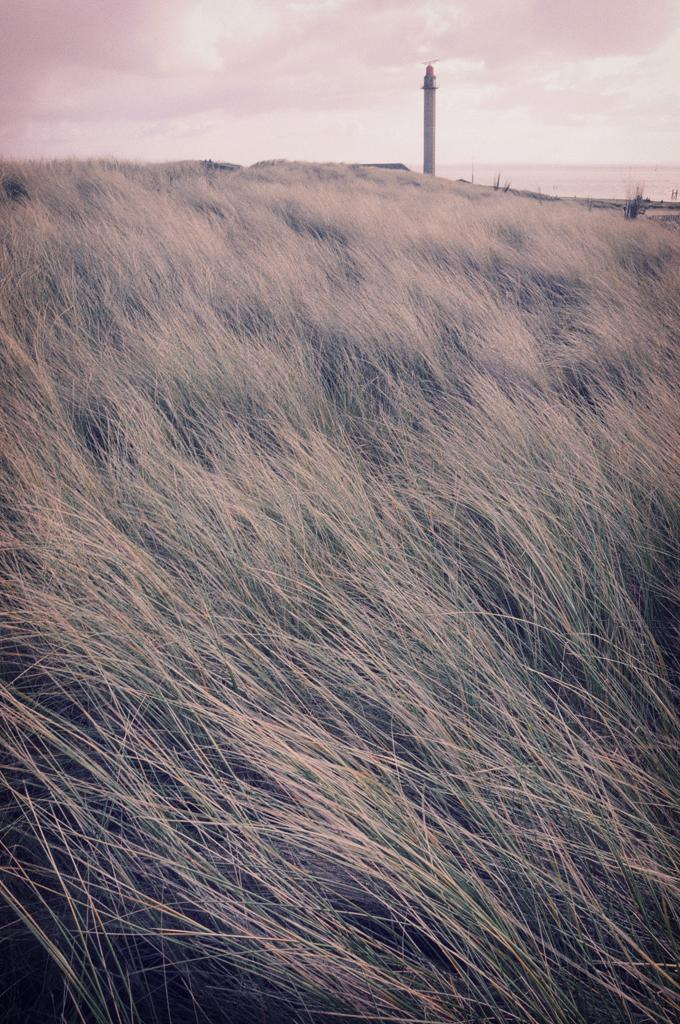What type of vegetation is in the foreground of the image? There is grass in the foreground of the image. What type of structure can be seen in the background of the image? There is a lighthouse in the background of the image. What natural element is visible in the background of the image? There is water visible in the background of the image. What else can be seen in the sky in the background of the image? There are clouds visible in the background of the image. What type of bead is hanging from the lighthouse in the image? There is no bead hanging from the lighthouse in the image. What reward is being given to the person in the image? There is no person in the image, and therefore no reward being given. 